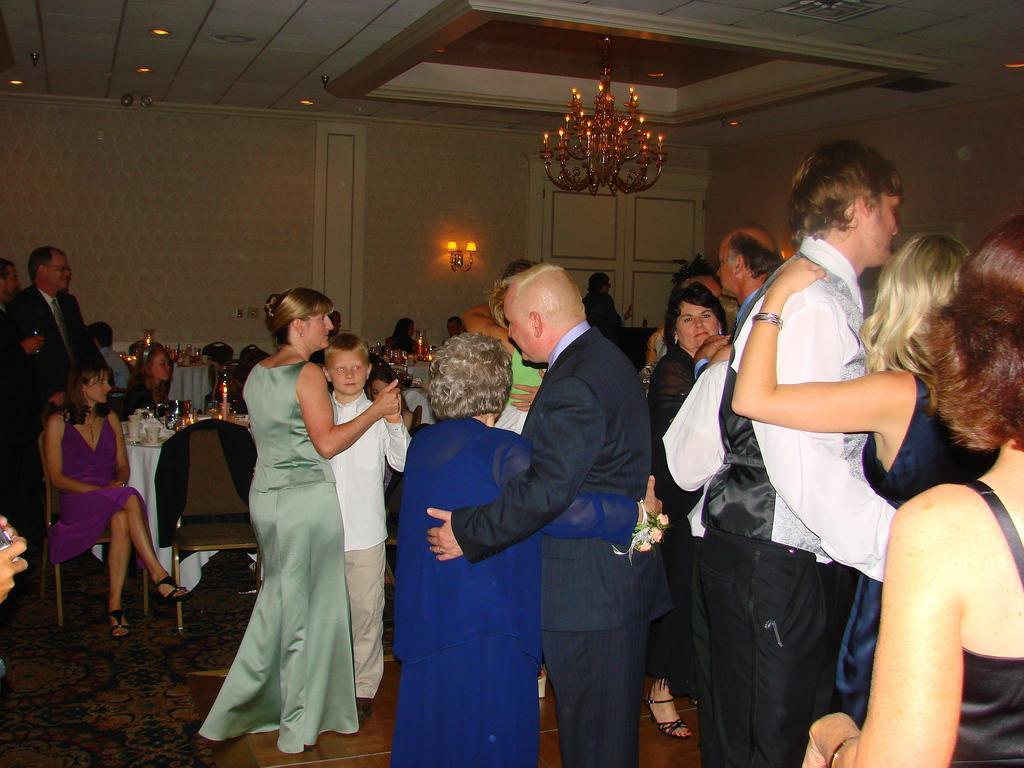Please provide a concise description of this image. There are groups of people standing and holding each other. I can see few people sitting on the chairs. This is a table covered with a cloth. I can see few objects placed on the table. I think this is a chandelier, which is hanging to the ceiling. This is a lamp, which is attached to a wall. In the background, I think this is a door. 